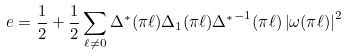<formula> <loc_0><loc_0><loc_500><loc_500>e = \frac { 1 } { 2 } + \frac { 1 } { 2 } \sum _ { \ell \neq 0 } \Delta ^ { \ast } ( \pi \ell ) \Delta _ { 1 } ( \pi \ell ) { \Delta ^ { \ast } } ^ { - 1 } ( \pi \ell ) \left | \omega ( \pi \ell ) \right | ^ { 2 }</formula> 